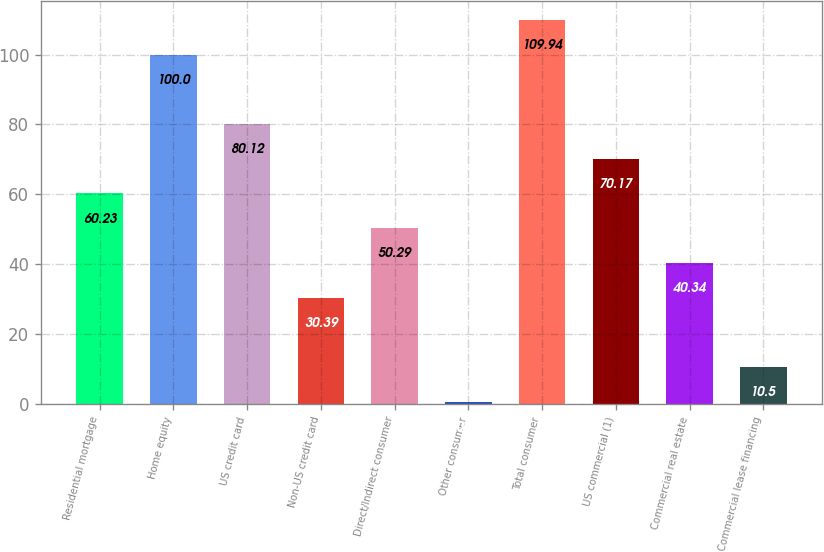Convert chart. <chart><loc_0><loc_0><loc_500><loc_500><bar_chart><fcel>Residential mortgage<fcel>Home equity<fcel>US credit card<fcel>Non-US credit card<fcel>Direct/Indirect consumer<fcel>Other consumer<fcel>Total consumer<fcel>US commercial (1)<fcel>Commercial real estate<fcel>Commercial lease financing<nl><fcel>60.23<fcel>100<fcel>80.12<fcel>30.39<fcel>50.29<fcel>0.55<fcel>109.94<fcel>70.17<fcel>40.34<fcel>10.5<nl></chart> 